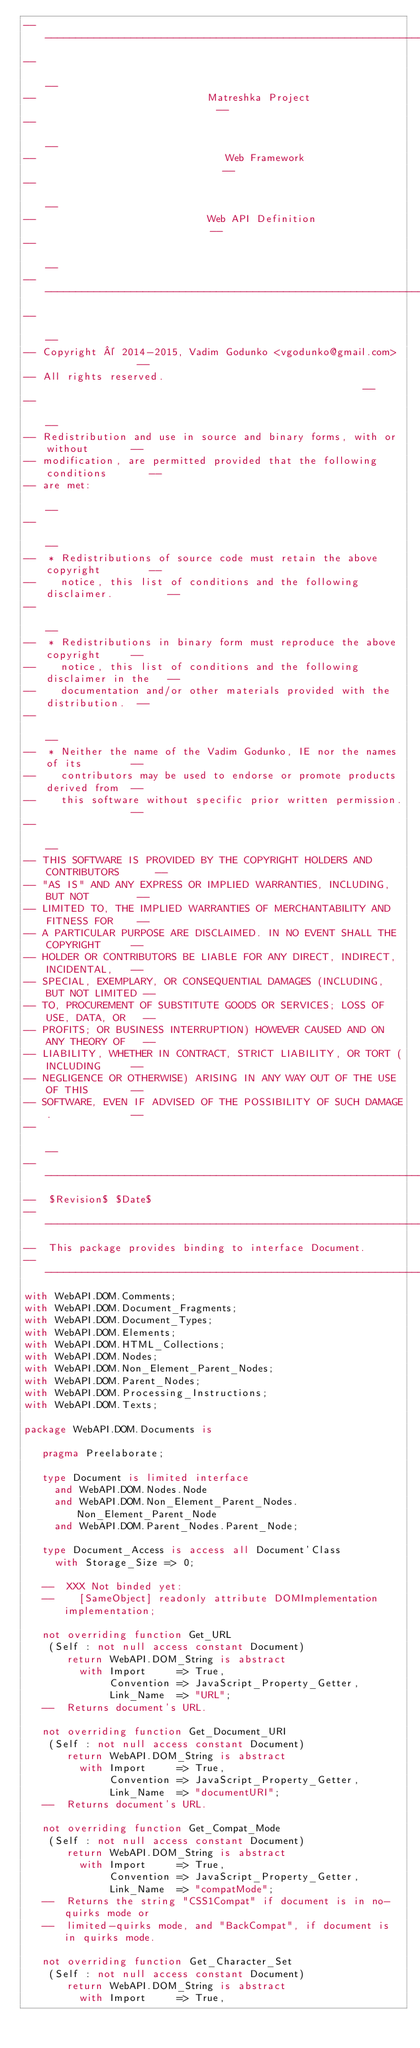<code> <loc_0><loc_0><loc_500><loc_500><_Ada_>------------------------------------------------------------------------------
--                                                                          --
--                            Matreshka Project                             --
--                                                                          --
--                               Web Framework                              --
--                                                                          --
--                            Web API Definition                            --
--                                                                          --
------------------------------------------------------------------------------
--                                                                          --
-- Copyright © 2014-2015, Vadim Godunko <vgodunko@gmail.com>                --
-- All rights reserved.                                                     --
--                                                                          --
-- Redistribution and use in source and binary forms, with or without       --
-- modification, are permitted provided that the following conditions       --
-- are met:                                                                 --
--                                                                          --
--  * Redistributions of source code must retain the above copyright        --
--    notice, this list of conditions and the following disclaimer.         --
--                                                                          --
--  * Redistributions in binary form must reproduce the above copyright     --
--    notice, this list of conditions and the following disclaimer in the   --
--    documentation and/or other materials provided with the distribution.  --
--                                                                          --
--  * Neither the name of the Vadim Godunko, IE nor the names of its        --
--    contributors may be used to endorse or promote products derived from  --
--    this software without specific prior written permission.              --
--                                                                          --
-- THIS SOFTWARE IS PROVIDED BY THE COPYRIGHT HOLDERS AND CONTRIBUTORS      --
-- "AS IS" AND ANY EXPRESS OR IMPLIED WARRANTIES, INCLUDING, BUT NOT        --
-- LIMITED TO, THE IMPLIED WARRANTIES OF MERCHANTABILITY AND FITNESS FOR    --
-- A PARTICULAR PURPOSE ARE DISCLAIMED. IN NO EVENT SHALL THE COPYRIGHT     --
-- HOLDER OR CONTRIBUTORS BE LIABLE FOR ANY DIRECT, INDIRECT, INCIDENTAL,   --
-- SPECIAL, EXEMPLARY, OR CONSEQUENTIAL DAMAGES (INCLUDING, BUT NOT LIMITED --
-- TO, PROCUREMENT OF SUBSTITUTE GOODS OR SERVICES; LOSS OF USE, DATA, OR   --
-- PROFITS; OR BUSINESS INTERRUPTION) HOWEVER CAUSED AND ON ANY THEORY OF   --
-- LIABILITY, WHETHER IN CONTRACT, STRICT LIABILITY, OR TORT (INCLUDING     --
-- NEGLIGENCE OR OTHERWISE) ARISING IN ANY WAY OUT OF THE USE OF THIS       --
-- SOFTWARE, EVEN IF ADVISED OF THE POSSIBILITY OF SUCH DAMAGE.             --
--                                                                          --
------------------------------------------------------------------------------
--  $Revision$ $Date$
------------------------------------------------------------------------------
--  This package provides binding to interface Document.
------------------------------------------------------------------------------
with WebAPI.DOM.Comments;
with WebAPI.DOM.Document_Fragments;
with WebAPI.DOM.Document_Types;
with WebAPI.DOM.Elements;
with WebAPI.DOM.HTML_Collections;
with WebAPI.DOM.Nodes;
with WebAPI.DOM.Non_Element_Parent_Nodes;
with WebAPI.DOM.Parent_Nodes;
with WebAPI.DOM.Processing_Instructions;
with WebAPI.DOM.Texts;

package WebAPI.DOM.Documents is

   pragma Preelaborate;

   type Document is limited interface
     and WebAPI.DOM.Nodes.Node
     and WebAPI.DOM.Non_Element_Parent_Nodes.Non_Element_Parent_Node
     and WebAPI.DOM.Parent_Nodes.Parent_Node;

   type Document_Access is access all Document'Class
     with Storage_Size => 0;

   --  XXX Not binded yet:
   --    [SameObject] readonly attribute DOMImplementation implementation;

   not overriding function Get_URL
    (Self : not null access constant Document)
       return WebAPI.DOM_String is abstract
         with Import     => True,
              Convention => JavaScript_Property_Getter,
              Link_Name  => "URL";
   --  Returns document's URL.

   not overriding function Get_Document_URI
    (Self : not null access constant Document)
       return WebAPI.DOM_String is abstract
         with Import     => True,
              Convention => JavaScript_Property_Getter,
              Link_Name  => "documentURI";
   --  Returns document's URL.

   not overriding function Get_Compat_Mode
    (Self : not null access constant Document)
       return WebAPI.DOM_String is abstract
         with Import     => True,
              Convention => JavaScript_Property_Getter,
              Link_Name  => "compatMode";
   --  Returns the string "CSS1Compat" if document is in no-quirks mode or
   --  limited-quirks mode, and "BackCompat", if document is in quirks mode.

   not overriding function Get_Character_Set
    (Self : not null access constant Document)
       return WebAPI.DOM_String is abstract
         with Import     => True,</code> 